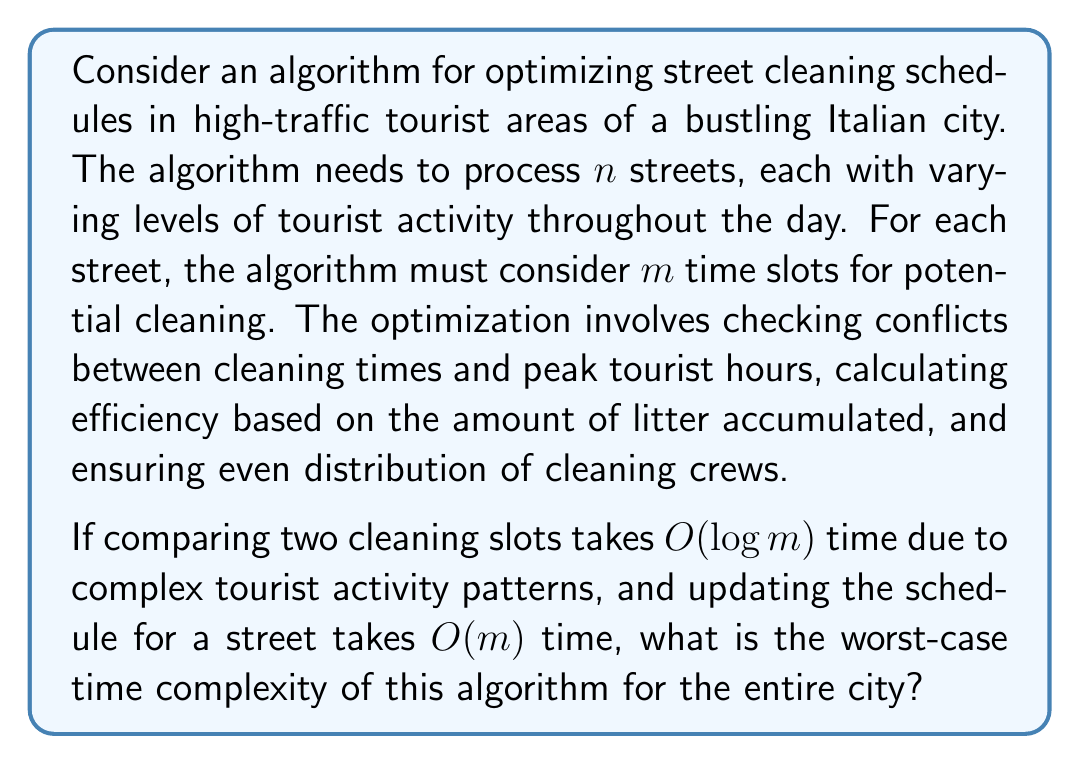Teach me how to tackle this problem. Let's break down the problem and analyze it step by step:

1) For each street, we need to consider $m$ time slots.

2) For each time slot, we need to compare it with other slots to check for conflicts and efficiency. This comparison takes $O(\log m)$ time.

3) After finding the optimal slot, updating the schedule takes $O(m)$ time.

4) These operations need to be performed for all $m$ slots of a street.

5) The process is then repeated for all $n$ streets in the city.

Let's calculate the complexity:

For a single street:
- Comparisons: $O(m \cdot \log m)$
- Updating schedule: $O(m)$

Total for one street: $O(m \cdot \log m + m) = O(m \cdot \log m)$

For all $n$ streets:
$O(n \cdot m \cdot \log m)$

This is the worst-case time complexity, which occurs when we need to process all slots for all streets.

In big O notation, we typically express this as $O(nm \log m)$.
Answer: $O(nm \log m)$ 